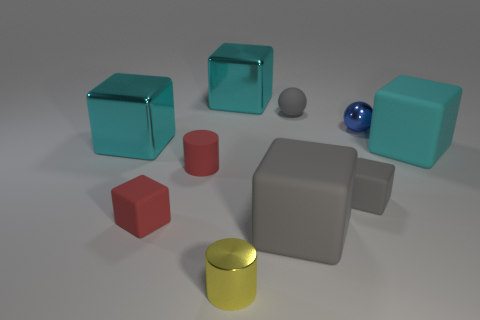What number of large objects are either blue shiny spheres or gray spheres?
Keep it short and to the point. 0. There is a red matte thing that is in front of the small gray matte object in front of the large metal object that is left of the yellow object; what is its size?
Ensure brevity in your answer.  Small. Are there any other things that have the same color as the tiny shiny ball?
Give a very brief answer. No. There is a tiny gray thing that is behind the cyan cube on the right side of the big block that is behind the blue metallic thing; what is its material?
Make the answer very short. Rubber. Does the large cyan matte thing have the same shape as the yellow object?
Keep it short and to the point. No. What number of big matte cubes are both to the left of the small blue shiny ball and behind the red block?
Your response must be concise. 0. There is a tiny shiny object to the right of the big cube that is in front of the tiny red cylinder; what color is it?
Provide a short and direct response. Blue. Are there the same number of tiny cylinders that are behind the blue metal sphere and rubber cubes?
Your answer should be very brief. No. What number of tiny gray spheres are in front of the large metal block behind the small ball that is behind the tiny blue object?
Keep it short and to the point. 1. There is a big metal block that is behind the gray ball; what color is it?
Give a very brief answer. Cyan. 